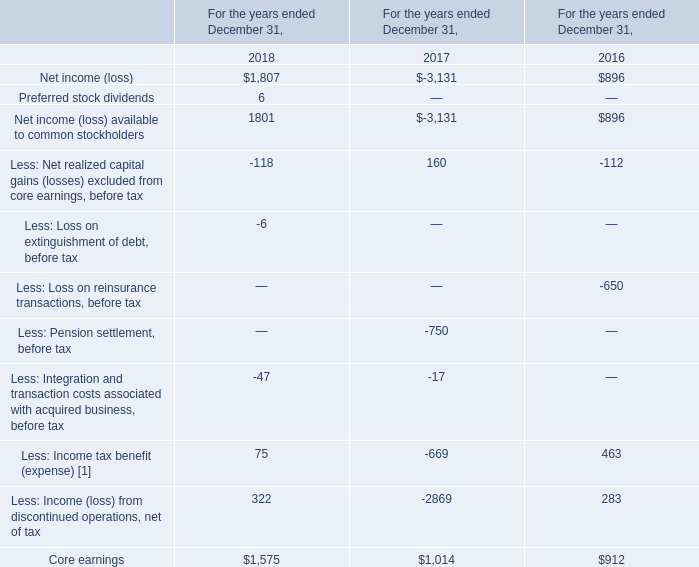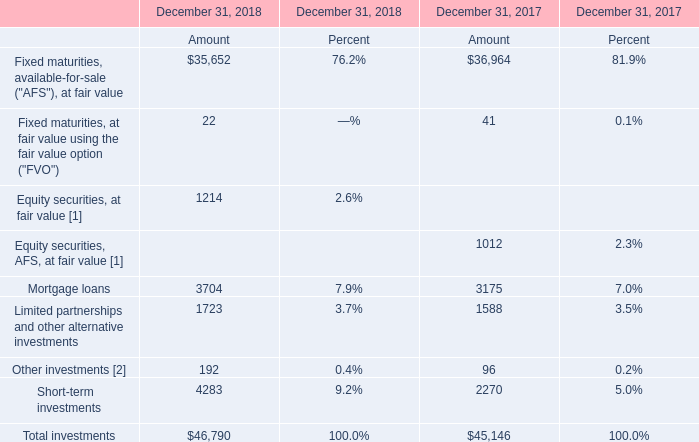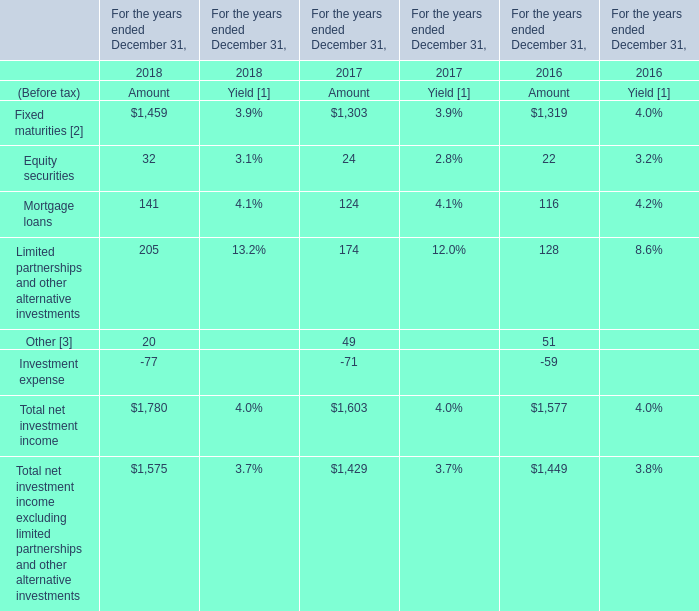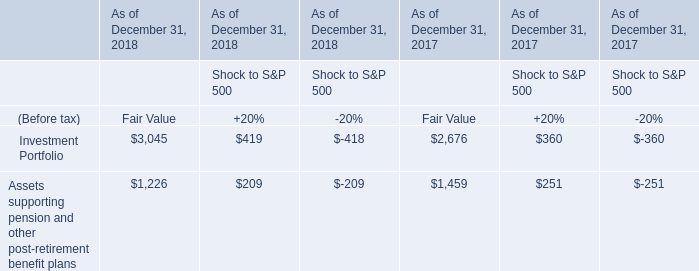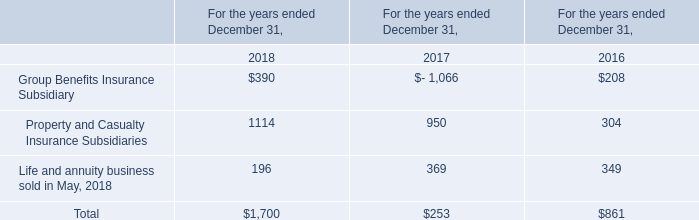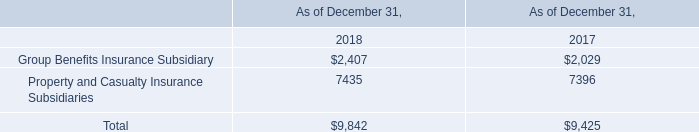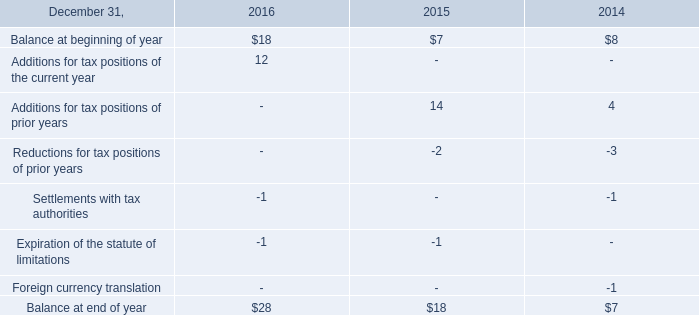what was the decrease observed in the deferred purchase price receivable during 2015 and 2016? 
Computations: ((83 - 249) / 249)
Answer: -0.66667. 